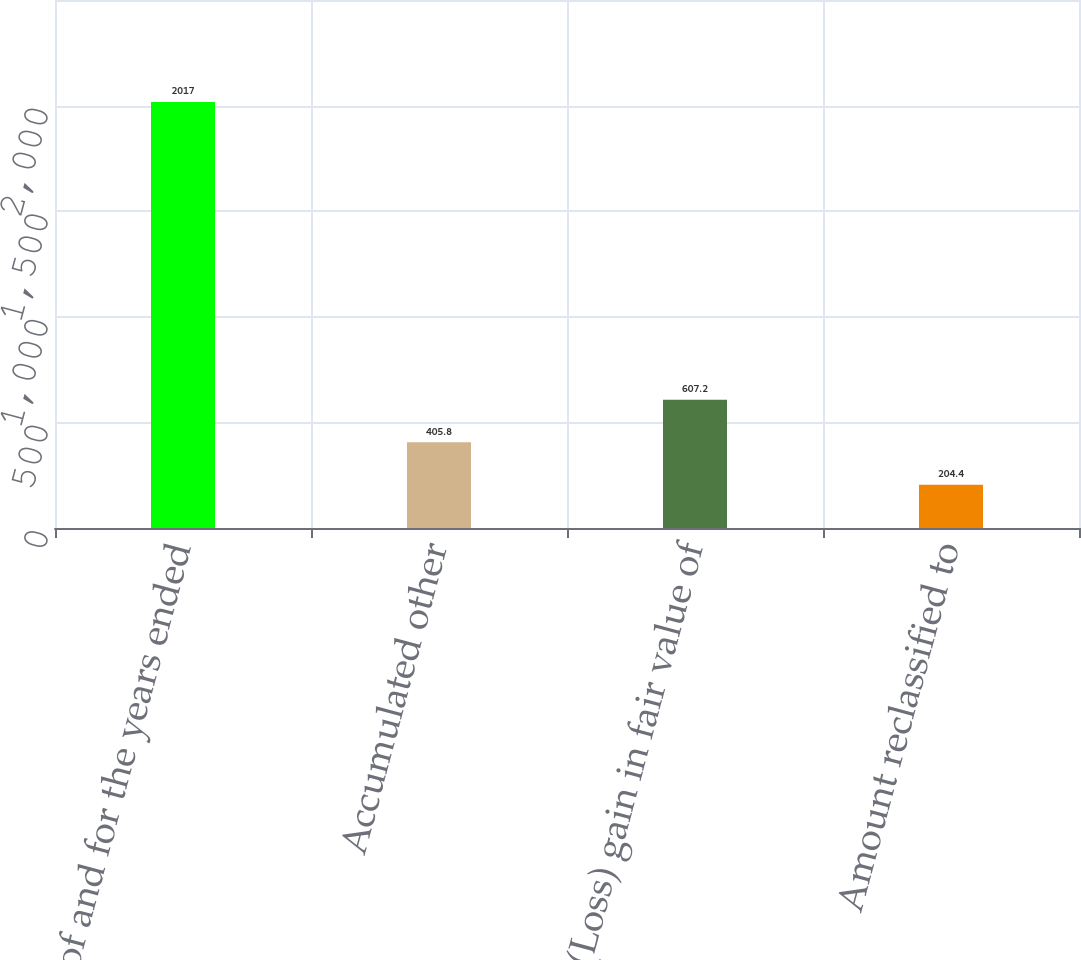Convert chart. <chart><loc_0><loc_0><loc_500><loc_500><bar_chart><fcel>as of and for the years ended<fcel>Accumulated other<fcel>(Loss) gain in fair value of<fcel>Amount reclassified to<nl><fcel>2017<fcel>405.8<fcel>607.2<fcel>204.4<nl></chart> 